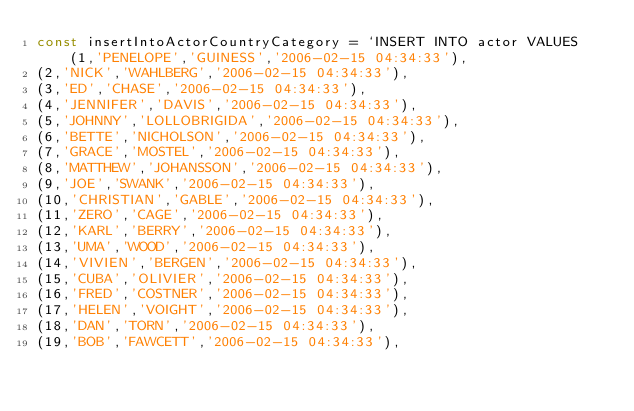<code> <loc_0><loc_0><loc_500><loc_500><_JavaScript_>const insertIntoActorCountryCategory = `INSERT INTO actor VALUES (1,'PENELOPE','GUINESS','2006-02-15 04:34:33'),
(2,'NICK','WAHLBERG','2006-02-15 04:34:33'),
(3,'ED','CHASE','2006-02-15 04:34:33'),
(4,'JENNIFER','DAVIS','2006-02-15 04:34:33'),
(5,'JOHNNY','LOLLOBRIGIDA','2006-02-15 04:34:33'),
(6,'BETTE','NICHOLSON','2006-02-15 04:34:33'),
(7,'GRACE','MOSTEL','2006-02-15 04:34:33'),
(8,'MATTHEW','JOHANSSON','2006-02-15 04:34:33'),
(9,'JOE','SWANK','2006-02-15 04:34:33'),
(10,'CHRISTIAN','GABLE','2006-02-15 04:34:33'),
(11,'ZERO','CAGE','2006-02-15 04:34:33'),
(12,'KARL','BERRY','2006-02-15 04:34:33'),
(13,'UMA','WOOD','2006-02-15 04:34:33'),
(14,'VIVIEN','BERGEN','2006-02-15 04:34:33'),
(15,'CUBA','OLIVIER','2006-02-15 04:34:33'),
(16,'FRED','COSTNER','2006-02-15 04:34:33'),
(17,'HELEN','VOIGHT','2006-02-15 04:34:33'),
(18,'DAN','TORN','2006-02-15 04:34:33'),
(19,'BOB','FAWCETT','2006-02-15 04:34:33'),</code> 